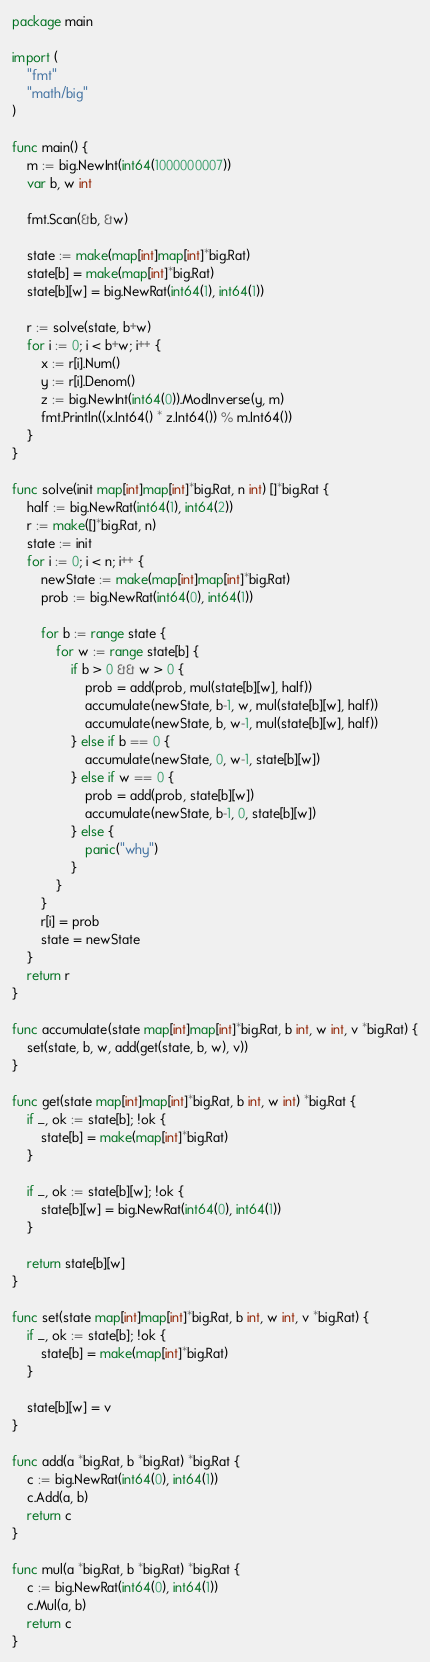Convert code to text. <code><loc_0><loc_0><loc_500><loc_500><_Go_>package main

import (
	"fmt"
	"math/big"
)

func main() {
	m := big.NewInt(int64(1000000007))
	var b, w int

	fmt.Scan(&b, &w)

	state := make(map[int]map[int]*big.Rat)
	state[b] = make(map[int]*big.Rat)
	state[b][w] = big.NewRat(int64(1), int64(1))

	r := solve(state, b+w)
	for i := 0; i < b+w; i++ {
		x := r[i].Num()
		y := r[i].Denom()
		z := big.NewInt(int64(0)).ModInverse(y, m)
		fmt.Println((x.Int64() * z.Int64()) % m.Int64())
	}
}

func solve(init map[int]map[int]*big.Rat, n int) []*big.Rat {
	half := big.NewRat(int64(1), int64(2))
	r := make([]*big.Rat, n)
	state := init
	for i := 0; i < n; i++ {
		newState := make(map[int]map[int]*big.Rat)
		prob := big.NewRat(int64(0), int64(1))

		for b := range state {
			for w := range state[b] {
				if b > 0 && w > 0 {
					prob = add(prob, mul(state[b][w], half))
					accumulate(newState, b-1, w, mul(state[b][w], half))
					accumulate(newState, b, w-1, mul(state[b][w], half))
				} else if b == 0 {
					accumulate(newState, 0, w-1, state[b][w])
				} else if w == 0 {
					prob = add(prob, state[b][w])
					accumulate(newState, b-1, 0, state[b][w])
				} else {
					panic("why")
				}
			}
		}
		r[i] = prob
		state = newState
	}
	return r
}

func accumulate(state map[int]map[int]*big.Rat, b int, w int, v *big.Rat) {
	set(state, b, w, add(get(state, b, w), v))
}

func get(state map[int]map[int]*big.Rat, b int, w int) *big.Rat {
	if _, ok := state[b]; !ok {
		state[b] = make(map[int]*big.Rat)
	}

	if _, ok := state[b][w]; !ok {
		state[b][w] = big.NewRat(int64(0), int64(1))
	}

	return state[b][w]
}

func set(state map[int]map[int]*big.Rat, b int, w int, v *big.Rat) {
	if _, ok := state[b]; !ok {
		state[b] = make(map[int]*big.Rat)
	}

	state[b][w] = v
}

func add(a *big.Rat, b *big.Rat) *big.Rat {
	c := big.NewRat(int64(0), int64(1))
	c.Add(a, b)
	return c
}

func mul(a *big.Rat, b *big.Rat) *big.Rat {
	c := big.NewRat(int64(0), int64(1))
	c.Mul(a, b)
	return c
}
</code> 